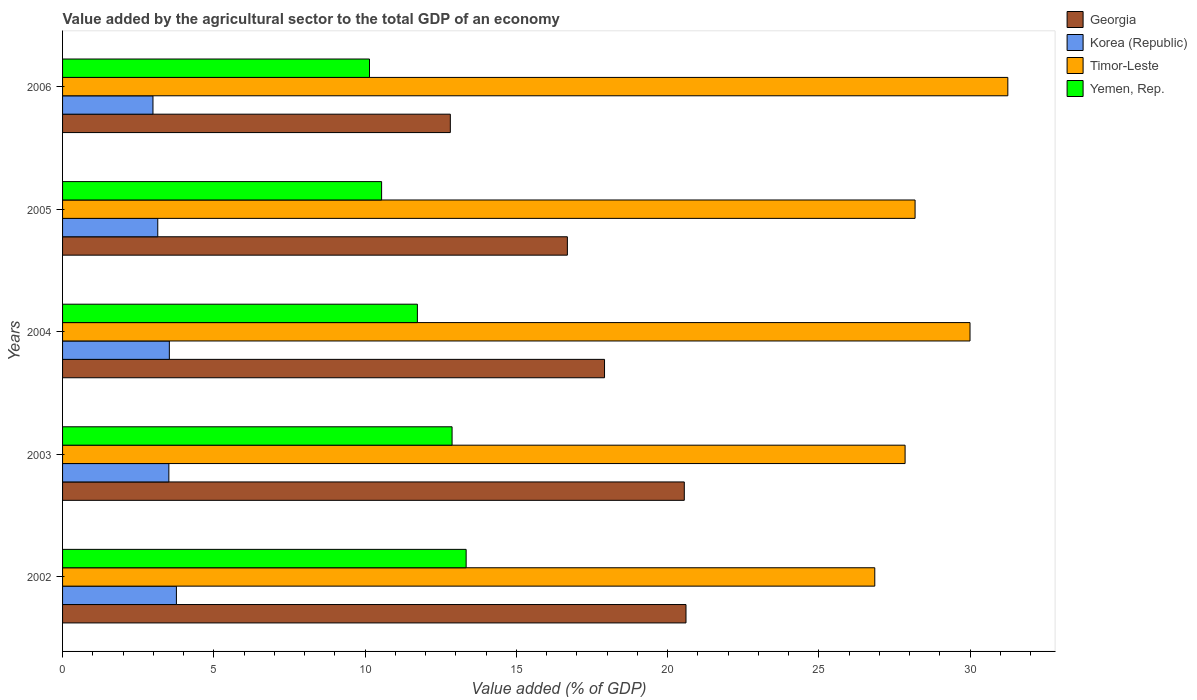Are the number of bars per tick equal to the number of legend labels?
Your answer should be compact. Yes. What is the value added by the agricultural sector to the total GDP in Yemen, Rep. in 2002?
Make the answer very short. 13.34. Across all years, what is the maximum value added by the agricultural sector to the total GDP in Korea (Republic)?
Provide a succinct answer. 3.76. Across all years, what is the minimum value added by the agricultural sector to the total GDP in Timor-Leste?
Make the answer very short. 26.85. In which year was the value added by the agricultural sector to the total GDP in Korea (Republic) minimum?
Ensure brevity in your answer.  2006. What is the total value added by the agricultural sector to the total GDP in Timor-Leste in the graph?
Keep it short and to the point. 144.14. What is the difference between the value added by the agricultural sector to the total GDP in Timor-Leste in 2002 and that in 2006?
Offer a terse response. -4.4. What is the difference between the value added by the agricultural sector to the total GDP in Korea (Republic) in 2006 and the value added by the agricultural sector to the total GDP in Timor-Leste in 2002?
Your answer should be compact. -23.86. What is the average value added by the agricultural sector to the total GDP in Georgia per year?
Provide a short and direct response. 17.72. In the year 2006, what is the difference between the value added by the agricultural sector to the total GDP in Korea (Republic) and value added by the agricultural sector to the total GDP in Yemen, Rep.?
Give a very brief answer. -7.16. In how many years, is the value added by the agricultural sector to the total GDP in Georgia greater than 26 %?
Your response must be concise. 0. What is the ratio of the value added by the agricultural sector to the total GDP in Yemen, Rep. in 2003 to that in 2005?
Make the answer very short. 1.22. Is the value added by the agricultural sector to the total GDP in Korea (Republic) in 2002 less than that in 2006?
Provide a short and direct response. No. What is the difference between the highest and the second highest value added by the agricultural sector to the total GDP in Yemen, Rep.?
Your answer should be very brief. 0.47. What is the difference between the highest and the lowest value added by the agricultural sector to the total GDP in Korea (Republic)?
Offer a very short reply. 0.77. Is the sum of the value added by the agricultural sector to the total GDP in Korea (Republic) in 2003 and 2004 greater than the maximum value added by the agricultural sector to the total GDP in Georgia across all years?
Make the answer very short. No. Is it the case that in every year, the sum of the value added by the agricultural sector to the total GDP in Korea (Republic) and value added by the agricultural sector to the total GDP in Timor-Leste is greater than the sum of value added by the agricultural sector to the total GDP in Georgia and value added by the agricultural sector to the total GDP in Yemen, Rep.?
Keep it short and to the point. Yes. What does the 4th bar from the top in 2003 represents?
Provide a short and direct response. Georgia. What does the 1st bar from the bottom in 2004 represents?
Your response must be concise. Georgia. Are all the bars in the graph horizontal?
Provide a succinct answer. Yes. How many years are there in the graph?
Ensure brevity in your answer.  5. Where does the legend appear in the graph?
Keep it short and to the point. Top right. How many legend labels are there?
Your answer should be compact. 4. How are the legend labels stacked?
Make the answer very short. Vertical. What is the title of the graph?
Your answer should be compact. Value added by the agricultural sector to the total GDP of an economy. Does "Dominica" appear as one of the legend labels in the graph?
Ensure brevity in your answer.  No. What is the label or title of the X-axis?
Your response must be concise. Value added (% of GDP). What is the label or title of the Y-axis?
Keep it short and to the point. Years. What is the Value added (% of GDP) of Georgia in 2002?
Offer a terse response. 20.61. What is the Value added (% of GDP) of Korea (Republic) in 2002?
Ensure brevity in your answer.  3.76. What is the Value added (% of GDP) in Timor-Leste in 2002?
Offer a terse response. 26.85. What is the Value added (% of GDP) of Yemen, Rep. in 2002?
Keep it short and to the point. 13.34. What is the Value added (% of GDP) in Georgia in 2003?
Keep it short and to the point. 20.55. What is the Value added (% of GDP) in Korea (Republic) in 2003?
Give a very brief answer. 3.51. What is the Value added (% of GDP) in Timor-Leste in 2003?
Your answer should be very brief. 27.85. What is the Value added (% of GDP) of Yemen, Rep. in 2003?
Provide a succinct answer. 12.88. What is the Value added (% of GDP) in Georgia in 2004?
Offer a very short reply. 17.92. What is the Value added (% of GDP) of Korea (Republic) in 2004?
Your response must be concise. 3.53. What is the Value added (% of GDP) of Timor-Leste in 2004?
Provide a short and direct response. 30. What is the Value added (% of GDP) in Yemen, Rep. in 2004?
Offer a terse response. 11.73. What is the Value added (% of GDP) of Georgia in 2005?
Give a very brief answer. 16.69. What is the Value added (% of GDP) of Korea (Republic) in 2005?
Your answer should be very brief. 3.15. What is the Value added (% of GDP) of Timor-Leste in 2005?
Ensure brevity in your answer.  28.18. What is the Value added (% of GDP) in Yemen, Rep. in 2005?
Your answer should be very brief. 10.55. What is the Value added (% of GDP) in Georgia in 2006?
Your response must be concise. 12.82. What is the Value added (% of GDP) in Korea (Republic) in 2006?
Provide a short and direct response. 2.99. What is the Value added (% of GDP) in Timor-Leste in 2006?
Give a very brief answer. 31.25. What is the Value added (% of GDP) of Yemen, Rep. in 2006?
Provide a short and direct response. 10.15. Across all years, what is the maximum Value added (% of GDP) of Georgia?
Your answer should be very brief. 20.61. Across all years, what is the maximum Value added (% of GDP) of Korea (Republic)?
Your answer should be very brief. 3.76. Across all years, what is the maximum Value added (% of GDP) in Timor-Leste?
Offer a very short reply. 31.25. Across all years, what is the maximum Value added (% of GDP) of Yemen, Rep.?
Your response must be concise. 13.34. Across all years, what is the minimum Value added (% of GDP) of Georgia?
Keep it short and to the point. 12.82. Across all years, what is the minimum Value added (% of GDP) of Korea (Republic)?
Give a very brief answer. 2.99. Across all years, what is the minimum Value added (% of GDP) in Timor-Leste?
Offer a very short reply. 26.85. Across all years, what is the minimum Value added (% of GDP) of Yemen, Rep.?
Your answer should be very brief. 10.15. What is the total Value added (% of GDP) of Georgia in the graph?
Your answer should be very brief. 88.59. What is the total Value added (% of GDP) in Korea (Republic) in the graph?
Offer a terse response. 16.94. What is the total Value added (% of GDP) of Timor-Leste in the graph?
Give a very brief answer. 144.14. What is the total Value added (% of GDP) of Yemen, Rep. in the graph?
Make the answer very short. 58.64. What is the difference between the Value added (% of GDP) of Georgia in 2002 and that in 2003?
Offer a terse response. 0.06. What is the difference between the Value added (% of GDP) in Korea (Republic) in 2002 and that in 2003?
Make the answer very short. 0.25. What is the difference between the Value added (% of GDP) in Timor-Leste in 2002 and that in 2003?
Give a very brief answer. -1. What is the difference between the Value added (% of GDP) of Yemen, Rep. in 2002 and that in 2003?
Offer a terse response. 0.47. What is the difference between the Value added (% of GDP) in Georgia in 2002 and that in 2004?
Offer a very short reply. 2.69. What is the difference between the Value added (% of GDP) in Korea (Republic) in 2002 and that in 2004?
Offer a terse response. 0.23. What is the difference between the Value added (% of GDP) in Timor-Leste in 2002 and that in 2004?
Make the answer very short. -3.15. What is the difference between the Value added (% of GDP) of Yemen, Rep. in 2002 and that in 2004?
Give a very brief answer. 1.61. What is the difference between the Value added (% of GDP) in Georgia in 2002 and that in 2005?
Offer a terse response. 3.92. What is the difference between the Value added (% of GDP) in Korea (Republic) in 2002 and that in 2005?
Your answer should be very brief. 0.62. What is the difference between the Value added (% of GDP) of Timor-Leste in 2002 and that in 2005?
Provide a short and direct response. -1.33. What is the difference between the Value added (% of GDP) of Yemen, Rep. in 2002 and that in 2005?
Your answer should be compact. 2.79. What is the difference between the Value added (% of GDP) in Georgia in 2002 and that in 2006?
Your response must be concise. 7.79. What is the difference between the Value added (% of GDP) of Korea (Republic) in 2002 and that in 2006?
Offer a very short reply. 0.77. What is the difference between the Value added (% of GDP) of Timor-Leste in 2002 and that in 2006?
Offer a terse response. -4.4. What is the difference between the Value added (% of GDP) in Yemen, Rep. in 2002 and that in 2006?
Your answer should be very brief. 3.2. What is the difference between the Value added (% of GDP) in Georgia in 2003 and that in 2004?
Ensure brevity in your answer.  2.64. What is the difference between the Value added (% of GDP) of Korea (Republic) in 2003 and that in 2004?
Ensure brevity in your answer.  -0.02. What is the difference between the Value added (% of GDP) of Timor-Leste in 2003 and that in 2004?
Provide a short and direct response. -2.15. What is the difference between the Value added (% of GDP) of Yemen, Rep. in 2003 and that in 2004?
Your response must be concise. 1.15. What is the difference between the Value added (% of GDP) in Georgia in 2003 and that in 2005?
Your answer should be compact. 3.87. What is the difference between the Value added (% of GDP) in Korea (Republic) in 2003 and that in 2005?
Your answer should be very brief. 0.37. What is the difference between the Value added (% of GDP) of Timor-Leste in 2003 and that in 2005?
Ensure brevity in your answer.  -0.33. What is the difference between the Value added (% of GDP) of Yemen, Rep. in 2003 and that in 2005?
Offer a terse response. 2.33. What is the difference between the Value added (% of GDP) in Georgia in 2003 and that in 2006?
Offer a very short reply. 7.74. What is the difference between the Value added (% of GDP) in Korea (Republic) in 2003 and that in 2006?
Your answer should be compact. 0.53. What is the difference between the Value added (% of GDP) of Timor-Leste in 2003 and that in 2006?
Provide a short and direct response. -3.4. What is the difference between the Value added (% of GDP) of Yemen, Rep. in 2003 and that in 2006?
Give a very brief answer. 2.73. What is the difference between the Value added (% of GDP) of Georgia in 2004 and that in 2005?
Keep it short and to the point. 1.23. What is the difference between the Value added (% of GDP) of Korea (Republic) in 2004 and that in 2005?
Your answer should be very brief. 0.38. What is the difference between the Value added (% of GDP) in Timor-Leste in 2004 and that in 2005?
Offer a very short reply. 1.82. What is the difference between the Value added (% of GDP) of Yemen, Rep. in 2004 and that in 2005?
Provide a succinct answer. 1.18. What is the difference between the Value added (% of GDP) in Georgia in 2004 and that in 2006?
Provide a succinct answer. 5.1. What is the difference between the Value added (% of GDP) of Korea (Republic) in 2004 and that in 2006?
Ensure brevity in your answer.  0.54. What is the difference between the Value added (% of GDP) in Timor-Leste in 2004 and that in 2006?
Give a very brief answer. -1.25. What is the difference between the Value added (% of GDP) in Yemen, Rep. in 2004 and that in 2006?
Provide a short and direct response. 1.58. What is the difference between the Value added (% of GDP) in Georgia in 2005 and that in 2006?
Provide a succinct answer. 3.87. What is the difference between the Value added (% of GDP) of Korea (Republic) in 2005 and that in 2006?
Ensure brevity in your answer.  0.16. What is the difference between the Value added (% of GDP) in Timor-Leste in 2005 and that in 2006?
Ensure brevity in your answer.  -3.07. What is the difference between the Value added (% of GDP) in Yemen, Rep. in 2005 and that in 2006?
Keep it short and to the point. 0.4. What is the difference between the Value added (% of GDP) in Georgia in 2002 and the Value added (% of GDP) in Korea (Republic) in 2003?
Keep it short and to the point. 17.1. What is the difference between the Value added (% of GDP) in Georgia in 2002 and the Value added (% of GDP) in Timor-Leste in 2003?
Provide a succinct answer. -7.24. What is the difference between the Value added (% of GDP) of Georgia in 2002 and the Value added (% of GDP) of Yemen, Rep. in 2003?
Your response must be concise. 7.73. What is the difference between the Value added (% of GDP) of Korea (Republic) in 2002 and the Value added (% of GDP) of Timor-Leste in 2003?
Your answer should be very brief. -24.09. What is the difference between the Value added (% of GDP) in Korea (Republic) in 2002 and the Value added (% of GDP) in Yemen, Rep. in 2003?
Your answer should be compact. -9.11. What is the difference between the Value added (% of GDP) of Timor-Leste in 2002 and the Value added (% of GDP) of Yemen, Rep. in 2003?
Make the answer very short. 13.97. What is the difference between the Value added (% of GDP) in Georgia in 2002 and the Value added (% of GDP) in Korea (Republic) in 2004?
Your response must be concise. 17.08. What is the difference between the Value added (% of GDP) in Georgia in 2002 and the Value added (% of GDP) in Timor-Leste in 2004?
Keep it short and to the point. -9.39. What is the difference between the Value added (% of GDP) in Georgia in 2002 and the Value added (% of GDP) in Yemen, Rep. in 2004?
Keep it short and to the point. 8.88. What is the difference between the Value added (% of GDP) in Korea (Republic) in 2002 and the Value added (% of GDP) in Timor-Leste in 2004?
Offer a very short reply. -26.24. What is the difference between the Value added (% of GDP) of Korea (Republic) in 2002 and the Value added (% of GDP) of Yemen, Rep. in 2004?
Your response must be concise. -7.97. What is the difference between the Value added (% of GDP) of Timor-Leste in 2002 and the Value added (% of GDP) of Yemen, Rep. in 2004?
Make the answer very short. 15.12. What is the difference between the Value added (% of GDP) in Georgia in 2002 and the Value added (% of GDP) in Korea (Republic) in 2005?
Give a very brief answer. 17.46. What is the difference between the Value added (% of GDP) of Georgia in 2002 and the Value added (% of GDP) of Timor-Leste in 2005?
Make the answer very short. -7.57. What is the difference between the Value added (% of GDP) of Georgia in 2002 and the Value added (% of GDP) of Yemen, Rep. in 2005?
Provide a short and direct response. 10.06. What is the difference between the Value added (% of GDP) in Korea (Republic) in 2002 and the Value added (% of GDP) in Timor-Leste in 2005?
Offer a terse response. -24.42. What is the difference between the Value added (% of GDP) in Korea (Republic) in 2002 and the Value added (% of GDP) in Yemen, Rep. in 2005?
Give a very brief answer. -6.78. What is the difference between the Value added (% of GDP) of Timor-Leste in 2002 and the Value added (% of GDP) of Yemen, Rep. in 2005?
Keep it short and to the point. 16.3. What is the difference between the Value added (% of GDP) in Georgia in 2002 and the Value added (% of GDP) in Korea (Republic) in 2006?
Give a very brief answer. 17.62. What is the difference between the Value added (% of GDP) of Georgia in 2002 and the Value added (% of GDP) of Timor-Leste in 2006?
Make the answer very short. -10.64. What is the difference between the Value added (% of GDP) of Georgia in 2002 and the Value added (% of GDP) of Yemen, Rep. in 2006?
Offer a very short reply. 10.46. What is the difference between the Value added (% of GDP) of Korea (Republic) in 2002 and the Value added (% of GDP) of Timor-Leste in 2006?
Your answer should be compact. -27.49. What is the difference between the Value added (% of GDP) in Korea (Republic) in 2002 and the Value added (% of GDP) in Yemen, Rep. in 2006?
Provide a short and direct response. -6.38. What is the difference between the Value added (% of GDP) of Timor-Leste in 2002 and the Value added (% of GDP) of Yemen, Rep. in 2006?
Offer a very short reply. 16.7. What is the difference between the Value added (% of GDP) of Georgia in 2003 and the Value added (% of GDP) of Korea (Republic) in 2004?
Ensure brevity in your answer.  17.02. What is the difference between the Value added (% of GDP) of Georgia in 2003 and the Value added (% of GDP) of Timor-Leste in 2004?
Offer a very short reply. -9.45. What is the difference between the Value added (% of GDP) in Georgia in 2003 and the Value added (% of GDP) in Yemen, Rep. in 2004?
Offer a terse response. 8.82. What is the difference between the Value added (% of GDP) in Korea (Republic) in 2003 and the Value added (% of GDP) in Timor-Leste in 2004?
Offer a very short reply. -26.49. What is the difference between the Value added (% of GDP) in Korea (Republic) in 2003 and the Value added (% of GDP) in Yemen, Rep. in 2004?
Provide a succinct answer. -8.22. What is the difference between the Value added (% of GDP) in Timor-Leste in 2003 and the Value added (% of GDP) in Yemen, Rep. in 2004?
Offer a very short reply. 16.12. What is the difference between the Value added (% of GDP) of Georgia in 2003 and the Value added (% of GDP) of Korea (Republic) in 2005?
Your answer should be compact. 17.41. What is the difference between the Value added (% of GDP) in Georgia in 2003 and the Value added (% of GDP) in Timor-Leste in 2005?
Offer a terse response. -7.63. What is the difference between the Value added (% of GDP) in Georgia in 2003 and the Value added (% of GDP) in Yemen, Rep. in 2005?
Offer a very short reply. 10.01. What is the difference between the Value added (% of GDP) of Korea (Republic) in 2003 and the Value added (% of GDP) of Timor-Leste in 2005?
Your answer should be compact. -24.67. What is the difference between the Value added (% of GDP) in Korea (Republic) in 2003 and the Value added (% of GDP) in Yemen, Rep. in 2005?
Offer a terse response. -7.03. What is the difference between the Value added (% of GDP) in Timor-Leste in 2003 and the Value added (% of GDP) in Yemen, Rep. in 2005?
Your response must be concise. 17.31. What is the difference between the Value added (% of GDP) in Georgia in 2003 and the Value added (% of GDP) in Korea (Republic) in 2006?
Offer a terse response. 17.57. What is the difference between the Value added (% of GDP) of Georgia in 2003 and the Value added (% of GDP) of Timor-Leste in 2006?
Offer a very short reply. -10.7. What is the difference between the Value added (% of GDP) of Georgia in 2003 and the Value added (% of GDP) of Yemen, Rep. in 2006?
Your answer should be compact. 10.41. What is the difference between the Value added (% of GDP) in Korea (Republic) in 2003 and the Value added (% of GDP) in Timor-Leste in 2006?
Ensure brevity in your answer.  -27.74. What is the difference between the Value added (% of GDP) in Korea (Republic) in 2003 and the Value added (% of GDP) in Yemen, Rep. in 2006?
Provide a short and direct response. -6.63. What is the difference between the Value added (% of GDP) of Timor-Leste in 2003 and the Value added (% of GDP) of Yemen, Rep. in 2006?
Your response must be concise. 17.71. What is the difference between the Value added (% of GDP) of Georgia in 2004 and the Value added (% of GDP) of Korea (Republic) in 2005?
Provide a short and direct response. 14.77. What is the difference between the Value added (% of GDP) of Georgia in 2004 and the Value added (% of GDP) of Timor-Leste in 2005?
Provide a succinct answer. -10.27. What is the difference between the Value added (% of GDP) in Georgia in 2004 and the Value added (% of GDP) in Yemen, Rep. in 2005?
Your answer should be compact. 7.37. What is the difference between the Value added (% of GDP) of Korea (Republic) in 2004 and the Value added (% of GDP) of Timor-Leste in 2005?
Provide a short and direct response. -24.65. What is the difference between the Value added (% of GDP) in Korea (Republic) in 2004 and the Value added (% of GDP) in Yemen, Rep. in 2005?
Your answer should be compact. -7.02. What is the difference between the Value added (% of GDP) in Timor-Leste in 2004 and the Value added (% of GDP) in Yemen, Rep. in 2005?
Offer a very short reply. 19.45. What is the difference between the Value added (% of GDP) in Georgia in 2004 and the Value added (% of GDP) in Korea (Republic) in 2006?
Ensure brevity in your answer.  14.93. What is the difference between the Value added (% of GDP) in Georgia in 2004 and the Value added (% of GDP) in Timor-Leste in 2006?
Offer a very short reply. -13.33. What is the difference between the Value added (% of GDP) of Georgia in 2004 and the Value added (% of GDP) of Yemen, Rep. in 2006?
Make the answer very short. 7.77. What is the difference between the Value added (% of GDP) in Korea (Republic) in 2004 and the Value added (% of GDP) in Timor-Leste in 2006?
Your response must be concise. -27.72. What is the difference between the Value added (% of GDP) in Korea (Republic) in 2004 and the Value added (% of GDP) in Yemen, Rep. in 2006?
Give a very brief answer. -6.62. What is the difference between the Value added (% of GDP) of Timor-Leste in 2004 and the Value added (% of GDP) of Yemen, Rep. in 2006?
Ensure brevity in your answer.  19.85. What is the difference between the Value added (% of GDP) in Georgia in 2005 and the Value added (% of GDP) in Korea (Republic) in 2006?
Your response must be concise. 13.7. What is the difference between the Value added (% of GDP) of Georgia in 2005 and the Value added (% of GDP) of Timor-Leste in 2006?
Offer a terse response. -14.56. What is the difference between the Value added (% of GDP) in Georgia in 2005 and the Value added (% of GDP) in Yemen, Rep. in 2006?
Offer a very short reply. 6.54. What is the difference between the Value added (% of GDP) in Korea (Republic) in 2005 and the Value added (% of GDP) in Timor-Leste in 2006?
Your answer should be compact. -28.1. What is the difference between the Value added (% of GDP) in Korea (Republic) in 2005 and the Value added (% of GDP) in Yemen, Rep. in 2006?
Make the answer very short. -7. What is the difference between the Value added (% of GDP) of Timor-Leste in 2005 and the Value added (% of GDP) of Yemen, Rep. in 2006?
Offer a terse response. 18.04. What is the average Value added (% of GDP) of Georgia per year?
Offer a terse response. 17.72. What is the average Value added (% of GDP) of Korea (Republic) per year?
Give a very brief answer. 3.39. What is the average Value added (% of GDP) in Timor-Leste per year?
Keep it short and to the point. 28.83. What is the average Value added (% of GDP) of Yemen, Rep. per year?
Your answer should be very brief. 11.73. In the year 2002, what is the difference between the Value added (% of GDP) in Georgia and Value added (% of GDP) in Korea (Republic)?
Give a very brief answer. 16.85. In the year 2002, what is the difference between the Value added (% of GDP) in Georgia and Value added (% of GDP) in Timor-Leste?
Provide a short and direct response. -6.24. In the year 2002, what is the difference between the Value added (% of GDP) of Georgia and Value added (% of GDP) of Yemen, Rep.?
Provide a succinct answer. 7.27. In the year 2002, what is the difference between the Value added (% of GDP) in Korea (Republic) and Value added (% of GDP) in Timor-Leste?
Your response must be concise. -23.09. In the year 2002, what is the difference between the Value added (% of GDP) in Korea (Republic) and Value added (% of GDP) in Yemen, Rep.?
Provide a succinct answer. -9.58. In the year 2002, what is the difference between the Value added (% of GDP) of Timor-Leste and Value added (% of GDP) of Yemen, Rep.?
Keep it short and to the point. 13.51. In the year 2003, what is the difference between the Value added (% of GDP) of Georgia and Value added (% of GDP) of Korea (Republic)?
Your answer should be very brief. 17.04. In the year 2003, what is the difference between the Value added (% of GDP) of Georgia and Value added (% of GDP) of Timor-Leste?
Provide a succinct answer. -7.3. In the year 2003, what is the difference between the Value added (% of GDP) in Georgia and Value added (% of GDP) in Yemen, Rep.?
Your answer should be very brief. 7.68. In the year 2003, what is the difference between the Value added (% of GDP) of Korea (Republic) and Value added (% of GDP) of Timor-Leste?
Your answer should be very brief. -24.34. In the year 2003, what is the difference between the Value added (% of GDP) of Korea (Republic) and Value added (% of GDP) of Yemen, Rep.?
Make the answer very short. -9.36. In the year 2003, what is the difference between the Value added (% of GDP) of Timor-Leste and Value added (% of GDP) of Yemen, Rep.?
Offer a very short reply. 14.98. In the year 2004, what is the difference between the Value added (% of GDP) in Georgia and Value added (% of GDP) in Korea (Republic)?
Your response must be concise. 14.39. In the year 2004, what is the difference between the Value added (% of GDP) of Georgia and Value added (% of GDP) of Timor-Leste?
Make the answer very short. -12.08. In the year 2004, what is the difference between the Value added (% of GDP) in Georgia and Value added (% of GDP) in Yemen, Rep.?
Your answer should be very brief. 6.19. In the year 2004, what is the difference between the Value added (% of GDP) in Korea (Republic) and Value added (% of GDP) in Timor-Leste?
Your answer should be compact. -26.47. In the year 2004, what is the difference between the Value added (% of GDP) of Korea (Republic) and Value added (% of GDP) of Yemen, Rep.?
Your answer should be compact. -8.2. In the year 2004, what is the difference between the Value added (% of GDP) in Timor-Leste and Value added (% of GDP) in Yemen, Rep.?
Keep it short and to the point. 18.27. In the year 2005, what is the difference between the Value added (% of GDP) in Georgia and Value added (% of GDP) in Korea (Republic)?
Your answer should be compact. 13.54. In the year 2005, what is the difference between the Value added (% of GDP) in Georgia and Value added (% of GDP) in Timor-Leste?
Your answer should be very brief. -11.49. In the year 2005, what is the difference between the Value added (% of GDP) of Georgia and Value added (% of GDP) of Yemen, Rep.?
Provide a short and direct response. 6.14. In the year 2005, what is the difference between the Value added (% of GDP) of Korea (Republic) and Value added (% of GDP) of Timor-Leste?
Ensure brevity in your answer.  -25.04. In the year 2005, what is the difference between the Value added (% of GDP) in Korea (Republic) and Value added (% of GDP) in Yemen, Rep.?
Your answer should be compact. -7.4. In the year 2005, what is the difference between the Value added (% of GDP) in Timor-Leste and Value added (% of GDP) in Yemen, Rep.?
Offer a very short reply. 17.64. In the year 2006, what is the difference between the Value added (% of GDP) in Georgia and Value added (% of GDP) in Korea (Republic)?
Make the answer very short. 9.83. In the year 2006, what is the difference between the Value added (% of GDP) in Georgia and Value added (% of GDP) in Timor-Leste?
Offer a very short reply. -18.43. In the year 2006, what is the difference between the Value added (% of GDP) of Georgia and Value added (% of GDP) of Yemen, Rep.?
Provide a short and direct response. 2.67. In the year 2006, what is the difference between the Value added (% of GDP) in Korea (Republic) and Value added (% of GDP) in Timor-Leste?
Keep it short and to the point. -28.26. In the year 2006, what is the difference between the Value added (% of GDP) in Korea (Republic) and Value added (% of GDP) in Yemen, Rep.?
Provide a short and direct response. -7.16. In the year 2006, what is the difference between the Value added (% of GDP) of Timor-Leste and Value added (% of GDP) of Yemen, Rep.?
Keep it short and to the point. 21.1. What is the ratio of the Value added (% of GDP) in Georgia in 2002 to that in 2003?
Offer a terse response. 1. What is the ratio of the Value added (% of GDP) of Korea (Republic) in 2002 to that in 2003?
Give a very brief answer. 1.07. What is the ratio of the Value added (% of GDP) in Timor-Leste in 2002 to that in 2003?
Your answer should be compact. 0.96. What is the ratio of the Value added (% of GDP) in Yemen, Rep. in 2002 to that in 2003?
Your response must be concise. 1.04. What is the ratio of the Value added (% of GDP) of Georgia in 2002 to that in 2004?
Ensure brevity in your answer.  1.15. What is the ratio of the Value added (% of GDP) in Korea (Republic) in 2002 to that in 2004?
Give a very brief answer. 1.07. What is the ratio of the Value added (% of GDP) of Timor-Leste in 2002 to that in 2004?
Your answer should be very brief. 0.9. What is the ratio of the Value added (% of GDP) of Yemen, Rep. in 2002 to that in 2004?
Make the answer very short. 1.14. What is the ratio of the Value added (% of GDP) of Georgia in 2002 to that in 2005?
Offer a terse response. 1.24. What is the ratio of the Value added (% of GDP) of Korea (Republic) in 2002 to that in 2005?
Provide a short and direct response. 1.2. What is the ratio of the Value added (% of GDP) of Timor-Leste in 2002 to that in 2005?
Offer a very short reply. 0.95. What is the ratio of the Value added (% of GDP) of Yemen, Rep. in 2002 to that in 2005?
Ensure brevity in your answer.  1.26. What is the ratio of the Value added (% of GDP) in Georgia in 2002 to that in 2006?
Offer a very short reply. 1.61. What is the ratio of the Value added (% of GDP) in Korea (Republic) in 2002 to that in 2006?
Your answer should be very brief. 1.26. What is the ratio of the Value added (% of GDP) in Timor-Leste in 2002 to that in 2006?
Ensure brevity in your answer.  0.86. What is the ratio of the Value added (% of GDP) in Yemen, Rep. in 2002 to that in 2006?
Make the answer very short. 1.31. What is the ratio of the Value added (% of GDP) in Georgia in 2003 to that in 2004?
Offer a very short reply. 1.15. What is the ratio of the Value added (% of GDP) in Timor-Leste in 2003 to that in 2004?
Offer a very short reply. 0.93. What is the ratio of the Value added (% of GDP) of Yemen, Rep. in 2003 to that in 2004?
Keep it short and to the point. 1.1. What is the ratio of the Value added (% of GDP) in Georgia in 2003 to that in 2005?
Provide a succinct answer. 1.23. What is the ratio of the Value added (% of GDP) in Korea (Republic) in 2003 to that in 2005?
Your answer should be very brief. 1.12. What is the ratio of the Value added (% of GDP) in Timor-Leste in 2003 to that in 2005?
Ensure brevity in your answer.  0.99. What is the ratio of the Value added (% of GDP) of Yemen, Rep. in 2003 to that in 2005?
Give a very brief answer. 1.22. What is the ratio of the Value added (% of GDP) in Georgia in 2003 to that in 2006?
Offer a terse response. 1.6. What is the ratio of the Value added (% of GDP) in Korea (Republic) in 2003 to that in 2006?
Offer a very short reply. 1.18. What is the ratio of the Value added (% of GDP) of Timor-Leste in 2003 to that in 2006?
Offer a very short reply. 0.89. What is the ratio of the Value added (% of GDP) of Yemen, Rep. in 2003 to that in 2006?
Make the answer very short. 1.27. What is the ratio of the Value added (% of GDP) in Georgia in 2004 to that in 2005?
Your answer should be compact. 1.07. What is the ratio of the Value added (% of GDP) of Korea (Republic) in 2004 to that in 2005?
Your response must be concise. 1.12. What is the ratio of the Value added (% of GDP) of Timor-Leste in 2004 to that in 2005?
Offer a very short reply. 1.06. What is the ratio of the Value added (% of GDP) of Yemen, Rep. in 2004 to that in 2005?
Ensure brevity in your answer.  1.11. What is the ratio of the Value added (% of GDP) of Georgia in 2004 to that in 2006?
Provide a short and direct response. 1.4. What is the ratio of the Value added (% of GDP) of Korea (Republic) in 2004 to that in 2006?
Offer a terse response. 1.18. What is the ratio of the Value added (% of GDP) of Timor-Leste in 2004 to that in 2006?
Your answer should be very brief. 0.96. What is the ratio of the Value added (% of GDP) in Yemen, Rep. in 2004 to that in 2006?
Provide a short and direct response. 1.16. What is the ratio of the Value added (% of GDP) in Georgia in 2005 to that in 2006?
Your answer should be compact. 1.3. What is the ratio of the Value added (% of GDP) in Korea (Republic) in 2005 to that in 2006?
Offer a terse response. 1.05. What is the ratio of the Value added (% of GDP) of Timor-Leste in 2005 to that in 2006?
Keep it short and to the point. 0.9. What is the ratio of the Value added (% of GDP) of Yemen, Rep. in 2005 to that in 2006?
Ensure brevity in your answer.  1.04. What is the difference between the highest and the second highest Value added (% of GDP) of Georgia?
Your answer should be compact. 0.06. What is the difference between the highest and the second highest Value added (% of GDP) in Korea (Republic)?
Offer a terse response. 0.23. What is the difference between the highest and the second highest Value added (% of GDP) in Timor-Leste?
Provide a short and direct response. 1.25. What is the difference between the highest and the second highest Value added (% of GDP) of Yemen, Rep.?
Give a very brief answer. 0.47. What is the difference between the highest and the lowest Value added (% of GDP) in Georgia?
Give a very brief answer. 7.79. What is the difference between the highest and the lowest Value added (% of GDP) in Korea (Republic)?
Offer a terse response. 0.77. What is the difference between the highest and the lowest Value added (% of GDP) of Timor-Leste?
Give a very brief answer. 4.4. What is the difference between the highest and the lowest Value added (% of GDP) in Yemen, Rep.?
Ensure brevity in your answer.  3.2. 